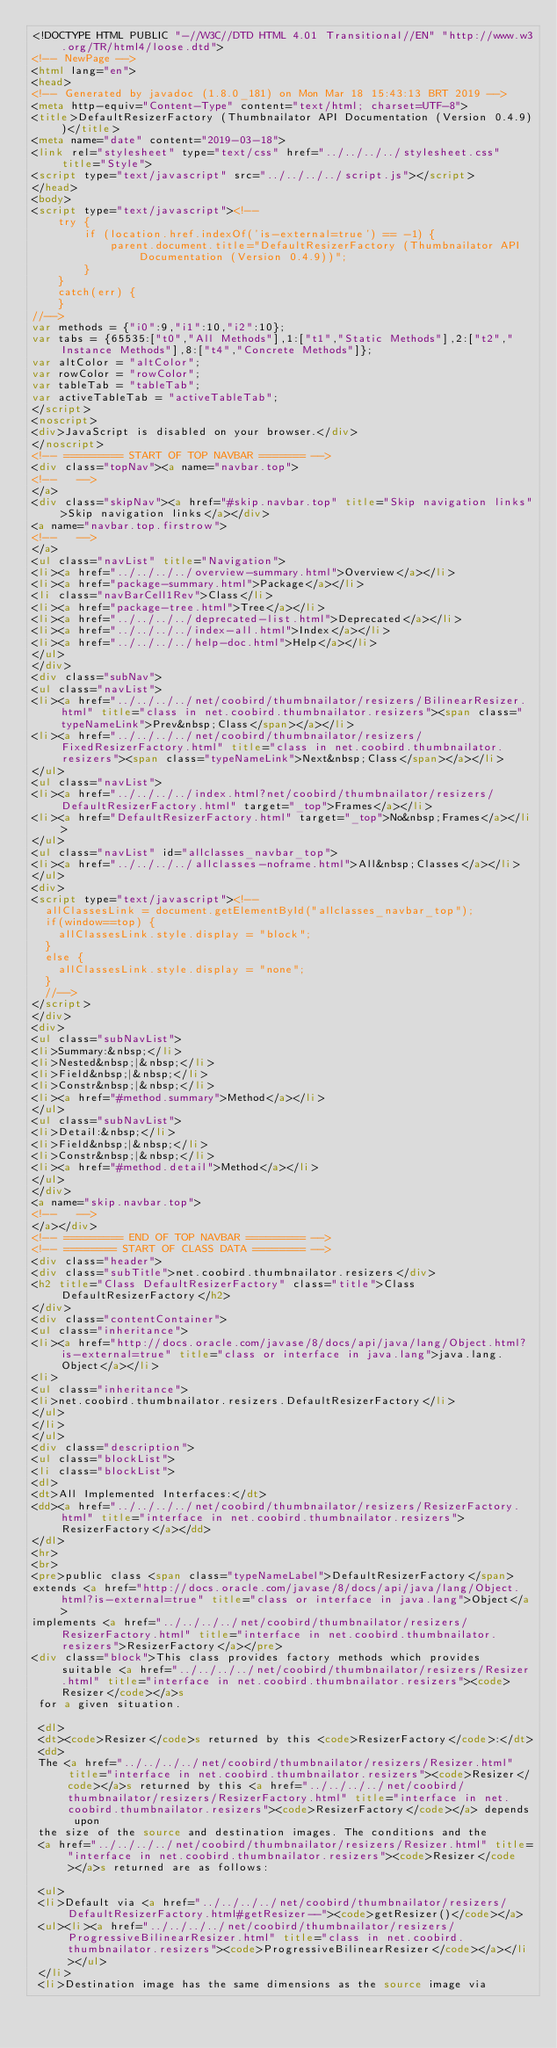Convert code to text. <code><loc_0><loc_0><loc_500><loc_500><_HTML_><!DOCTYPE HTML PUBLIC "-//W3C//DTD HTML 4.01 Transitional//EN" "http://www.w3.org/TR/html4/loose.dtd">
<!-- NewPage -->
<html lang="en">
<head>
<!-- Generated by javadoc (1.8.0_181) on Mon Mar 18 15:43:13 BRT 2019 -->
<meta http-equiv="Content-Type" content="text/html; charset=UTF-8">
<title>DefaultResizerFactory (Thumbnailator API Documentation (Version 0.4.9))</title>
<meta name="date" content="2019-03-18">
<link rel="stylesheet" type="text/css" href="../../../../stylesheet.css" title="Style">
<script type="text/javascript" src="../../../../script.js"></script>
</head>
<body>
<script type="text/javascript"><!--
    try {
        if (location.href.indexOf('is-external=true') == -1) {
            parent.document.title="DefaultResizerFactory (Thumbnailator API Documentation (Version 0.4.9))";
        }
    }
    catch(err) {
    }
//-->
var methods = {"i0":9,"i1":10,"i2":10};
var tabs = {65535:["t0","All Methods"],1:["t1","Static Methods"],2:["t2","Instance Methods"],8:["t4","Concrete Methods"]};
var altColor = "altColor";
var rowColor = "rowColor";
var tableTab = "tableTab";
var activeTableTab = "activeTableTab";
</script>
<noscript>
<div>JavaScript is disabled on your browser.</div>
</noscript>
<!-- ========= START OF TOP NAVBAR ======= -->
<div class="topNav"><a name="navbar.top">
<!--   -->
</a>
<div class="skipNav"><a href="#skip.navbar.top" title="Skip navigation links">Skip navigation links</a></div>
<a name="navbar.top.firstrow">
<!--   -->
</a>
<ul class="navList" title="Navigation">
<li><a href="../../../../overview-summary.html">Overview</a></li>
<li><a href="package-summary.html">Package</a></li>
<li class="navBarCell1Rev">Class</li>
<li><a href="package-tree.html">Tree</a></li>
<li><a href="../../../../deprecated-list.html">Deprecated</a></li>
<li><a href="../../../../index-all.html">Index</a></li>
<li><a href="../../../../help-doc.html">Help</a></li>
</ul>
</div>
<div class="subNav">
<ul class="navList">
<li><a href="../../../../net/coobird/thumbnailator/resizers/BilinearResizer.html" title="class in net.coobird.thumbnailator.resizers"><span class="typeNameLink">Prev&nbsp;Class</span></a></li>
<li><a href="../../../../net/coobird/thumbnailator/resizers/FixedResizerFactory.html" title="class in net.coobird.thumbnailator.resizers"><span class="typeNameLink">Next&nbsp;Class</span></a></li>
</ul>
<ul class="navList">
<li><a href="../../../../index.html?net/coobird/thumbnailator/resizers/DefaultResizerFactory.html" target="_top">Frames</a></li>
<li><a href="DefaultResizerFactory.html" target="_top">No&nbsp;Frames</a></li>
</ul>
<ul class="navList" id="allclasses_navbar_top">
<li><a href="../../../../allclasses-noframe.html">All&nbsp;Classes</a></li>
</ul>
<div>
<script type="text/javascript"><!--
  allClassesLink = document.getElementById("allclasses_navbar_top");
  if(window==top) {
    allClassesLink.style.display = "block";
  }
  else {
    allClassesLink.style.display = "none";
  }
  //-->
</script>
</div>
<div>
<ul class="subNavList">
<li>Summary:&nbsp;</li>
<li>Nested&nbsp;|&nbsp;</li>
<li>Field&nbsp;|&nbsp;</li>
<li>Constr&nbsp;|&nbsp;</li>
<li><a href="#method.summary">Method</a></li>
</ul>
<ul class="subNavList">
<li>Detail:&nbsp;</li>
<li>Field&nbsp;|&nbsp;</li>
<li>Constr&nbsp;|&nbsp;</li>
<li><a href="#method.detail">Method</a></li>
</ul>
</div>
<a name="skip.navbar.top">
<!--   -->
</a></div>
<!-- ========= END OF TOP NAVBAR ========= -->
<!-- ======== START OF CLASS DATA ======== -->
<div class="header">
<div class="subTitle">net.coobird.thumbnailator.resizers</div>
<h2 title="Class DefaultResizerFactory" class="title">Class DefaultResizerFactory</h2>
</div>
<div class="contentContainer">
<ul class="inheritance">
<li><a href="http://docs.oracle.com/javase/8/docs/api/java/lang/Object.html?is-external=true" title="class or interface in java.lang">java.lang.Object</a></li>
<li>
<ul class="inheritance">
<li>net.coobird.thumbnailator.resizers.DefaultResizerFactory</li>
</ul>
</li>
</ul>
<div class="description">
<ul class="blockList">
<li class="blockList">
<dl>
<dt>All Implemented Interfaces:</dt>
<dd><a href="../../../../net/coobird/thumbnailator/resizers/ResizerFactory.html" title="interface in net.coobird.thumbnailator.resizers">ResizerFactory</a></dd>
</dl>
<hr>
<br>
<pre>public class <span class="typeNameLabel">DefaultResizerFactory</span>
extends <a href="http://docs.oracle.com/javase/8/docs/api/java/lang/Object.html?is-external=true" title="class or interface in java.lang">Object</a>
implements <a href="../../../../net/coobird/thumbnailator/resizers/ResizerFactory.html" title="interface in net.coobird.thumbnailator.resizers">ResizerFactory</a></pre>
<div class="block">This class provides factory methods which provides suitable <a href="../../../../net/coobird/thumbnailator/resizers/Resizer.html" title="interface in net.coobird.thumbnailator.resizers"><code>Resizer</code></a>s
 for a given situation.

 <dl>
 <dt><code>Resizer</code>s returned by this <code>ResizerFactory</code>:</dt>
 <dd>
 The <a href="../../../../net/coobird/thumbnailator/resizers/Resizer.html" title="interface in net.coobird.thumbnailator.resizers"><code>Resizer</code></a>s returned by this <a href="../../../../net/coobird/thumbnailator/resizers/ResizerFactory.html" title="interface in net.coobird.thumbnailator.resizers"><code>ResizerFactory</code></a> depends upon
 the size of the source and destination images. The conditions and the
 <a href="../../../../net/coobird/thumbnailator/resizers/Resizer.html" title="interface in net.coobird.thumbnailator.resizers"><code>Resizer</code></a>s returned are as follows:

 <ul>
 <li>Default via <a href="../../../../net/coobird/thumbnailator/resizers/DefaultResizerFactory.html#getResizer--"><code>getResizer()</code></a>
 <ul><li><a href="../../../../net/coobird/thumbnailator/resizers/ProgressiveBilinearResizer.html" title="class in net.coobird.thumbnailator.resizers"><code>ProgressiveBilinearResizer</code></a></li></ul>
 </li>
 <li>Destination image has the same dimensions as the source image via</code> 